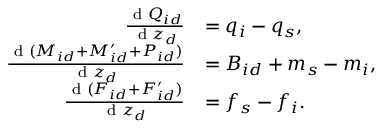Convert formula to latex. <formula><loc_0><loc_0><loc_500><loc_500>\begin{array} { r l } { \frac { d Q _ { i d } } { d z _ { d } } } & { = q _ { i } - q _ { s } , } \\ { \frac { d ( M _ { i d } + M _ { i d } ^ { \prime } + P _ { i d } ) } { d z _ { d } } } & { = B _ { i d } + m _ { s } - m _ { i } , } \\ { \frac { d ( F _ { i d } + F _ { i d } ^ { \prime } ) } { d z _ { d } } } & { = f _ { s } - f _ { i } . } \end{array}</formula> 